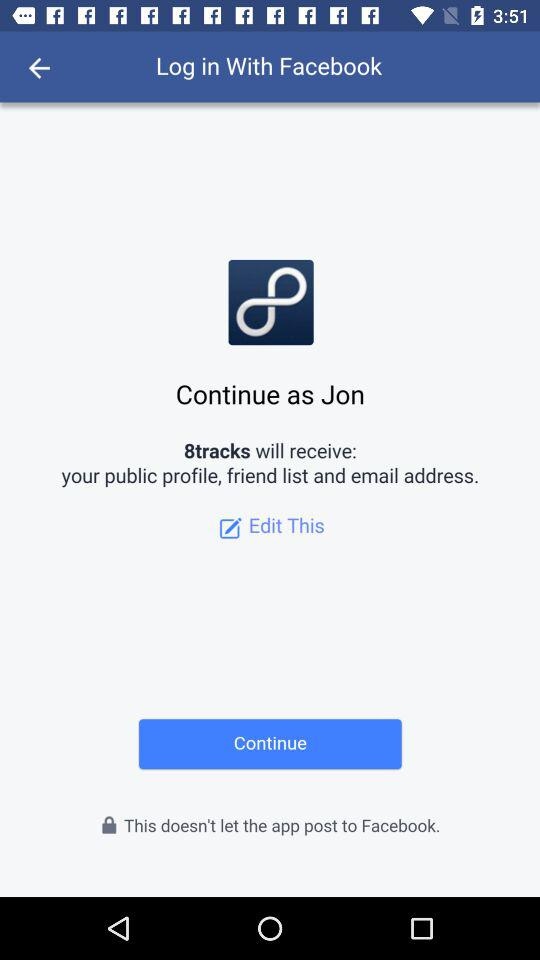What is the user name? The user name is Jon. 